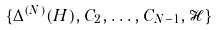<formula> <loc_0><loc_0><loc_500><loc_500>\{ \Delta ^ { ( N ) } ( H ) , C _ { 2 } , \dots , C _ { N - 1 } , \mathcal { H } \}</formula> 